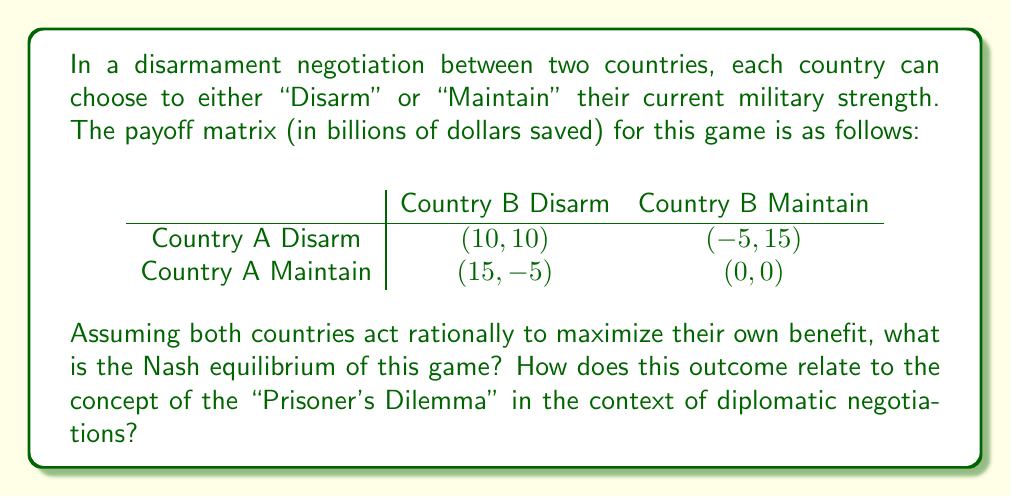Help me with this question. To find the Nash equilibrium, we need to analyze each country's best response to the other country's strategy:

1. If Country B chooses to Disarm:
   - Country A's best response is to Maintain (15 > 10)

2. If Country B chooses to Maintain:
   - Country A's best response is to Maintain (0 > -5)

3. If Country A chooses to Disarm:
   - Country B's best response is to Maintain (15 > 10)

4. If Country A chooses to Maintain:
   - Country B's best response is to Maintain (0 > -5)

From this analysis, we can see that regardless of what the other country does, each country's best strategy is to Maintain. Therefore, the Nash equilibrium is (Maintain, Maintain) with a payoff of (0, 0).

This outcome is similar to the Prisoner's Dilemma because:

1. The Nash equilibrium (Maintain, Maintain) is not the most efficient outcome. Both countries would be better off if they both chose to Disarm, resulting in a payoff of (10, 10).

2. The individual rational choice leads to a suboptimal collective outcome. Each country has an incentive to Maintain, even though mutual disarmament would be more beneficial for both.

3. Lack of trust and cooperation leads to a less desirable outcome. If countries could trust each other to Disarm, they would both be better off.

In the context of diplomatic negotiations, this game illustrates the challenges of achieving disarmament when countries act in their own self-interest. It highlights the importance of building trust, creating enforceable agreements, and aligning incentives to achieve more cooperative outcomes in international relations.
Answer: The Nash equilibrium of this game is (Maintain, Maintain) with a payoff of (0, 0). This outcome is similar to the Prisoner's Dilemma, as it demonstrates how individual rational choices can lead to suboptimal collective outcomes in diplomatic negotiations and disarmament efforts. 